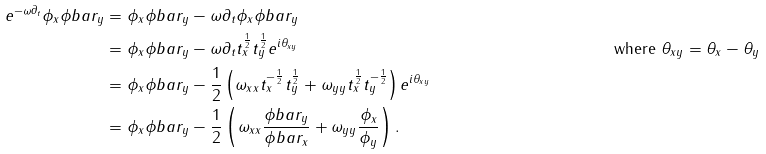<formula> <loc_0><loc_0><loc_500><loc_500>e ^ { - \omega \partial _ { t } } \phi _ { x } \phi b a r _ { y } & = \phi _ { x } \phi b a r _ { y } - \omega \partial _ { t } \phi _ { x } \phi b a r _ { y } \\ & = \phi _ { x } \phi b a r _ { y } - \omega \partial _ { t } t _ { x } ^ { \frac { 1 } { 2 } } t _ { y } ^ { \frac { 1 } { 2 } } e ^ { i \theta _ { x y } } & \text { where } \theta _ { x y } = \theta _ { x } - \theta _ { y } \\ & = \phi _ { x } \phi b a r _ { y } - \frac { 1 } { 2 } \left ( \omega _ { x x } t _ { x } ^ { - \frac { 1 } { 2 } } t _ { y } ^ { \frac { 1 } { 2 } } + \omega _ { y y } t _ { x } ^ { \frac { 1 } { 2 } } t _ { y } ^ { - \frac { 1 } { 2 } } \right ) e ^ { i \theta _ { x y } } \\ & = \phi _ { x } \phi b a r _ { y } - \frac { 1 } { 2 } \left ( \omega _ { x x } \frac { \phi b a r _ { y } } { \phi b a r _ { x } } + \omega _ { y y } \frac { \phi _ { x } } { \phi _ { y } } \right ) .</formula> 